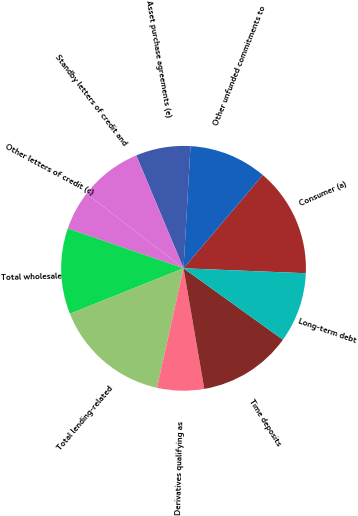Convert chart to OTSL. <chart><loc_0><loc_0><loc_500><loc_500><pie_chart><fcel>Consumer (a)<fcel>Other unfunded commitments to<fcel>Asset purchase agreements (e)<fcel>Standby letters of credit and<fcel>Other letters of credit (c)<fcel>Total wholesale<fcel>Total lending-related<fcel>Derivatives qualifying as<fcel>Time deposits<fcel>Long-term debt<nl><fcel>14.43%<fcel>10.31%<fcel>7.22%<fcel>8.25%<fcel>5.16%<fcel>11.34%<fcel>15.46%<fcel>6.19%<fcel>12.37%<fcel>9.28%<nl></chart> 